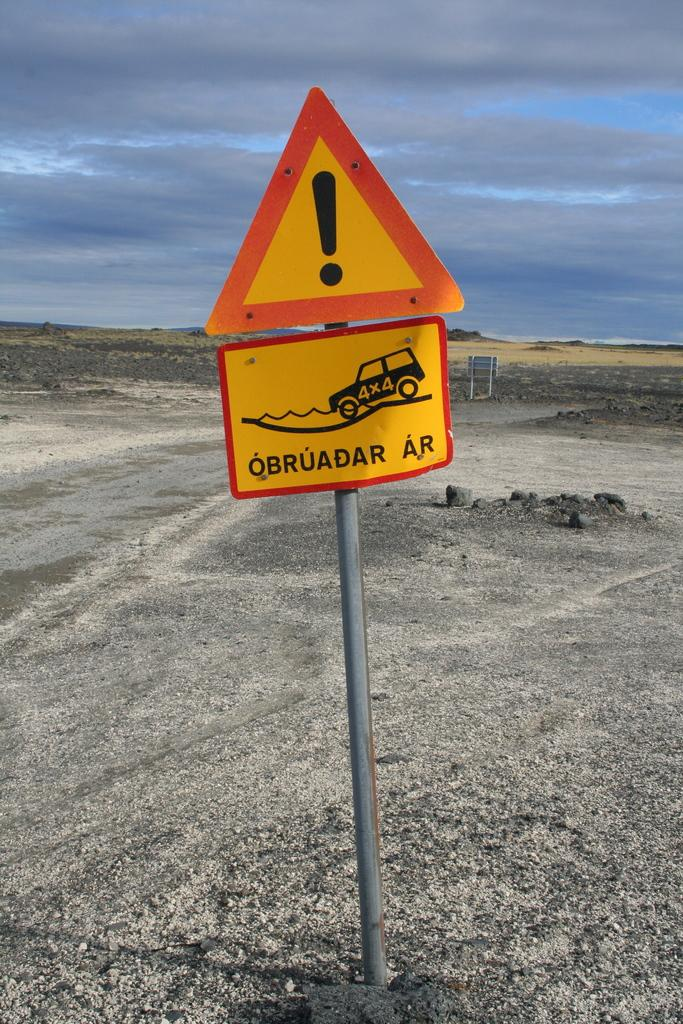<image>
Offer a succinct explanation of the picture presented. A caution sign with a 4x4 truck going into the water 